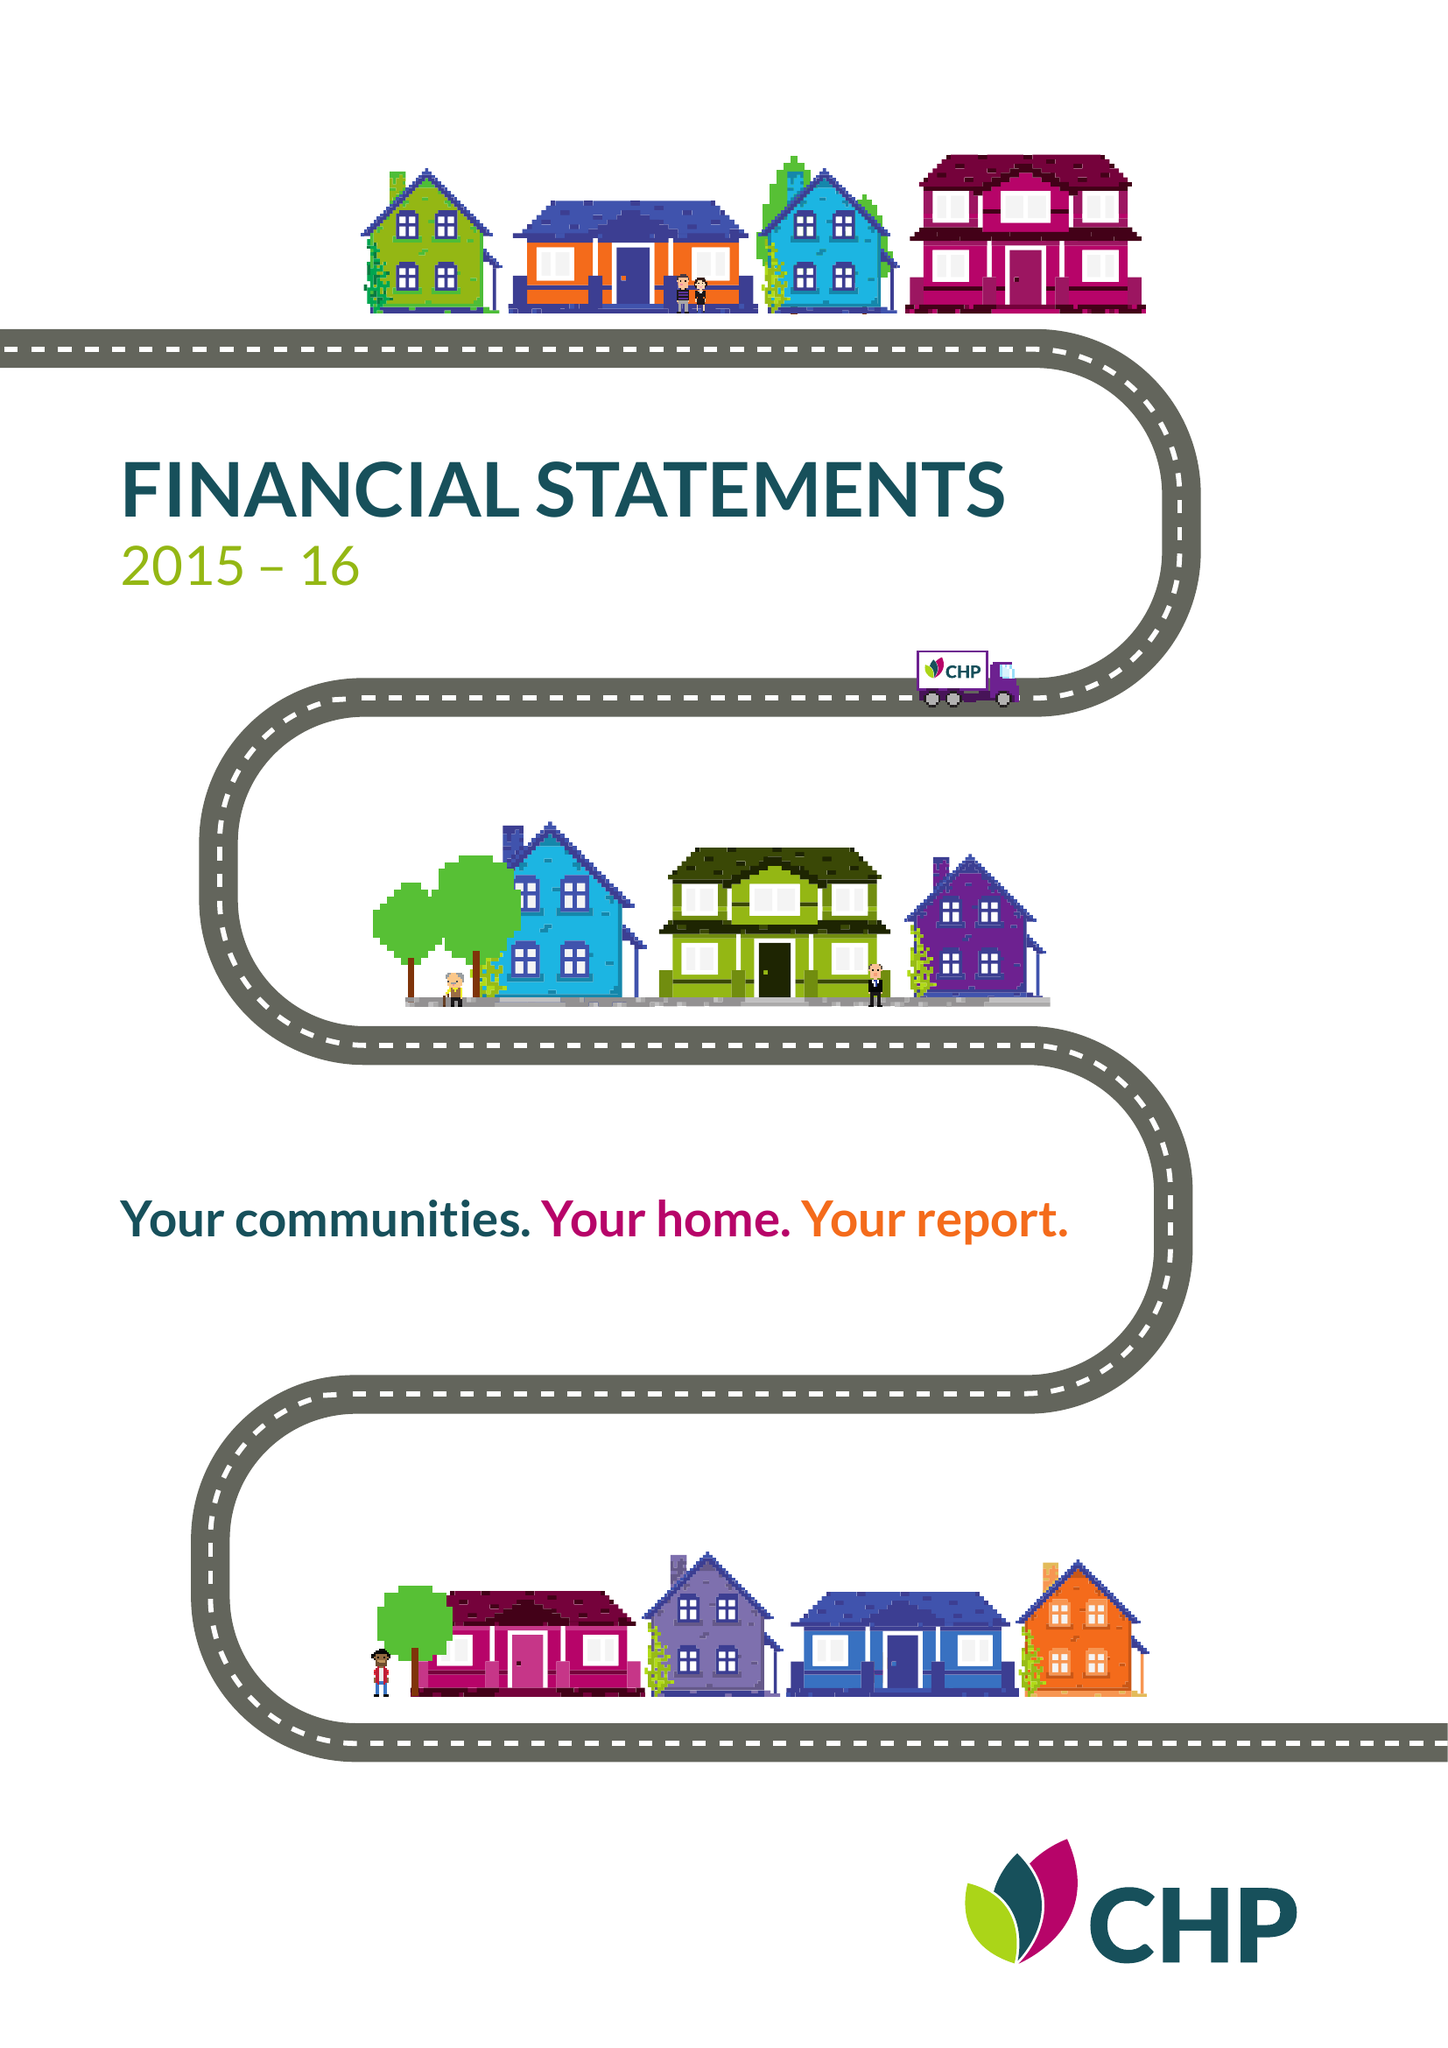What is the value for the spending_annually_in_british_pounds?
Answer the question using a single word or phrase. 46007000.00 